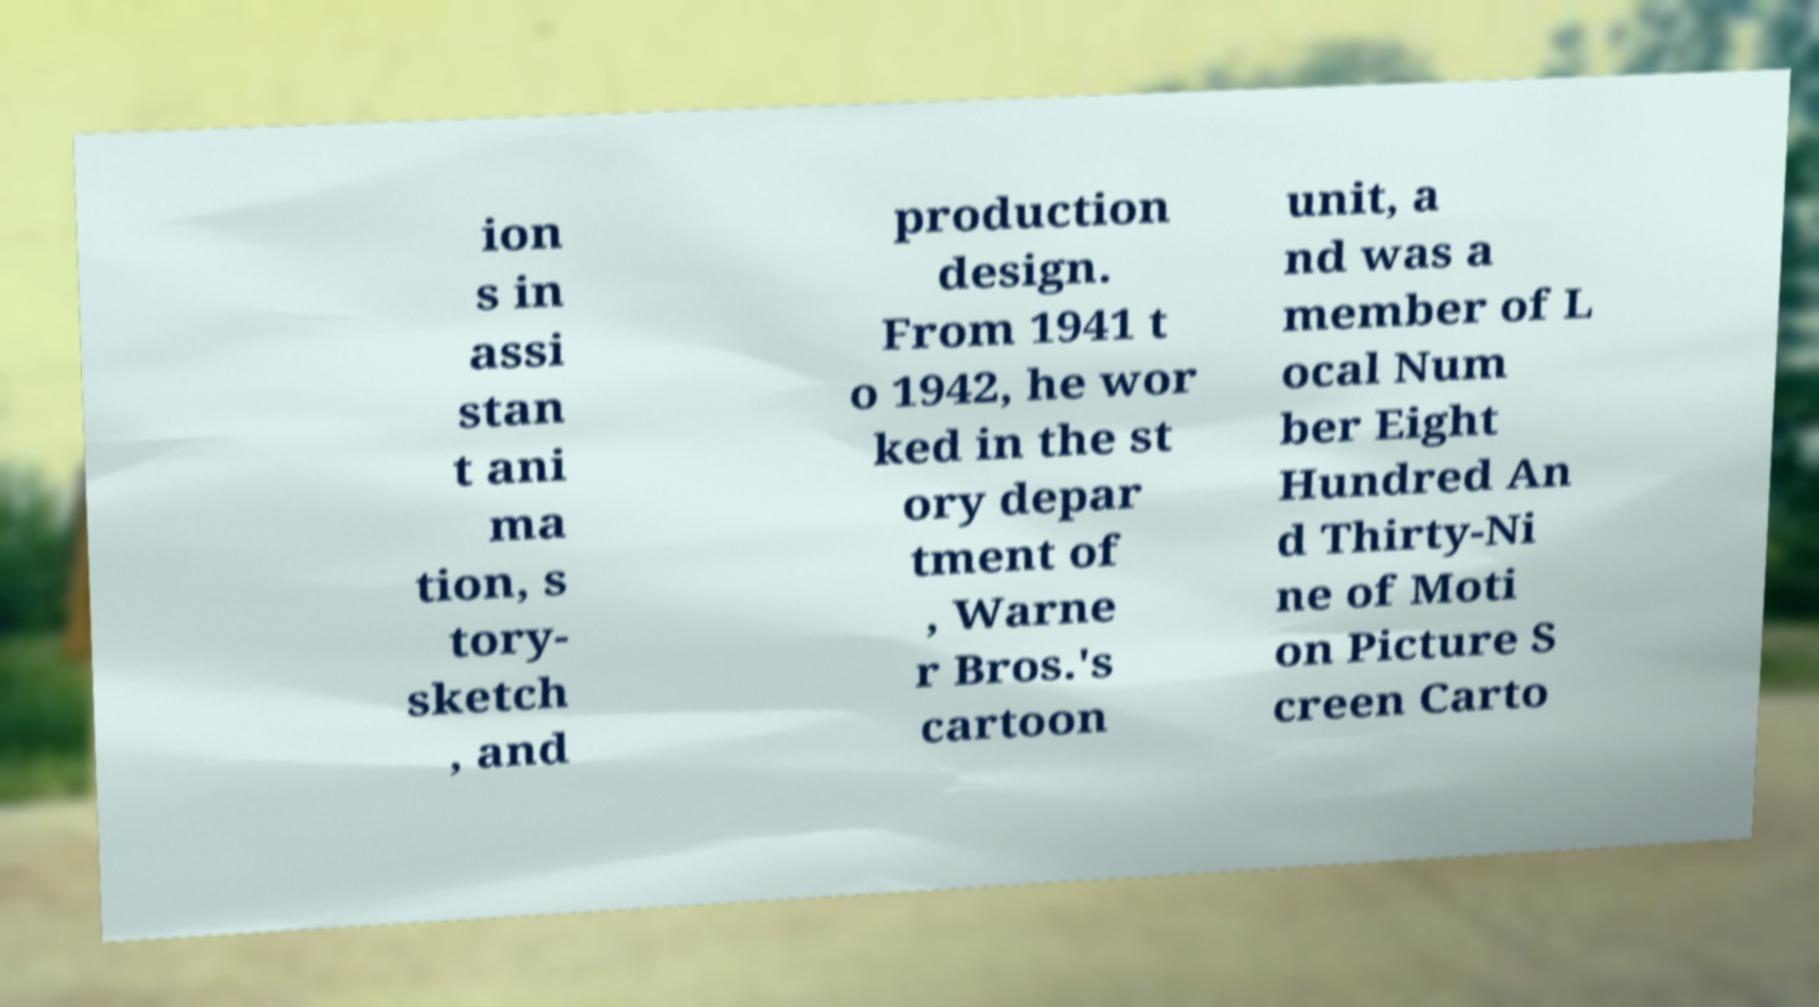What messages or text are displayed in this image? I need them in a readable, typed format. ion s in assi stan t ani ma tion, s tory- sketch , and production design. From 1941 t o 1942, he wor ked in the st ory depar tment of , Warne r Bros.'s cartoon unit, a nd was a member of L ocal Num ber Eight Hundred An d Thirty-Ni ne of Moti on Picture S creen Carto 